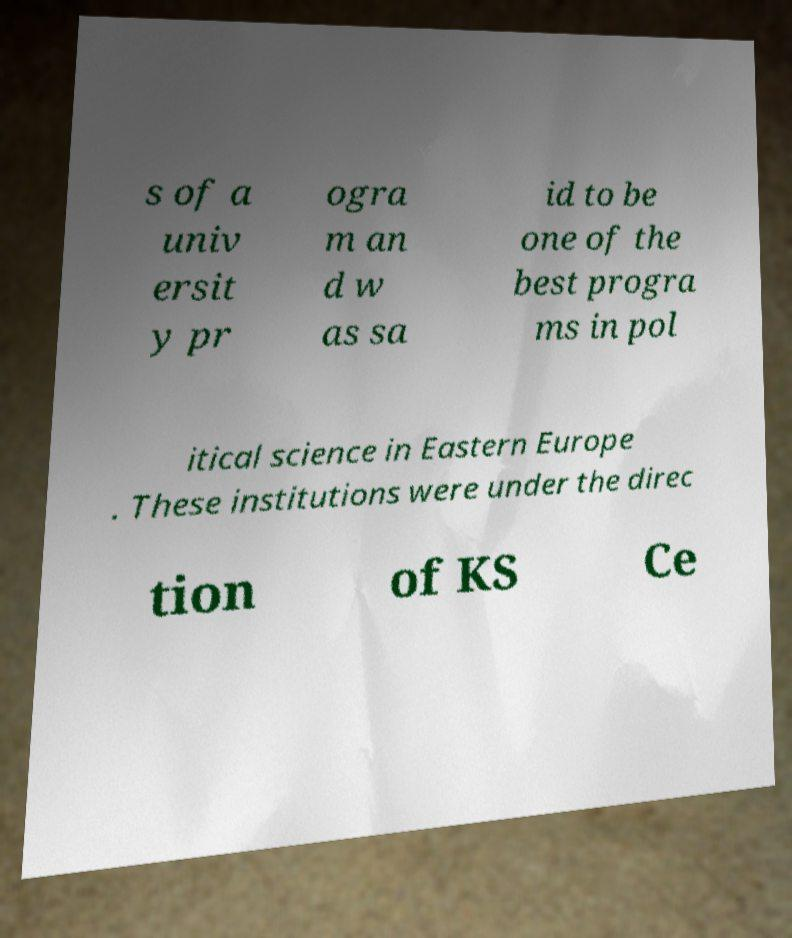I need the written content from this picture converted into text. Can you do that? s of a univ ersit y pr ogra m an d w as sa id to be one of the best progra ms in pol itical science in Eastern Europe . These institutions were under the direc tion of KS Ce 